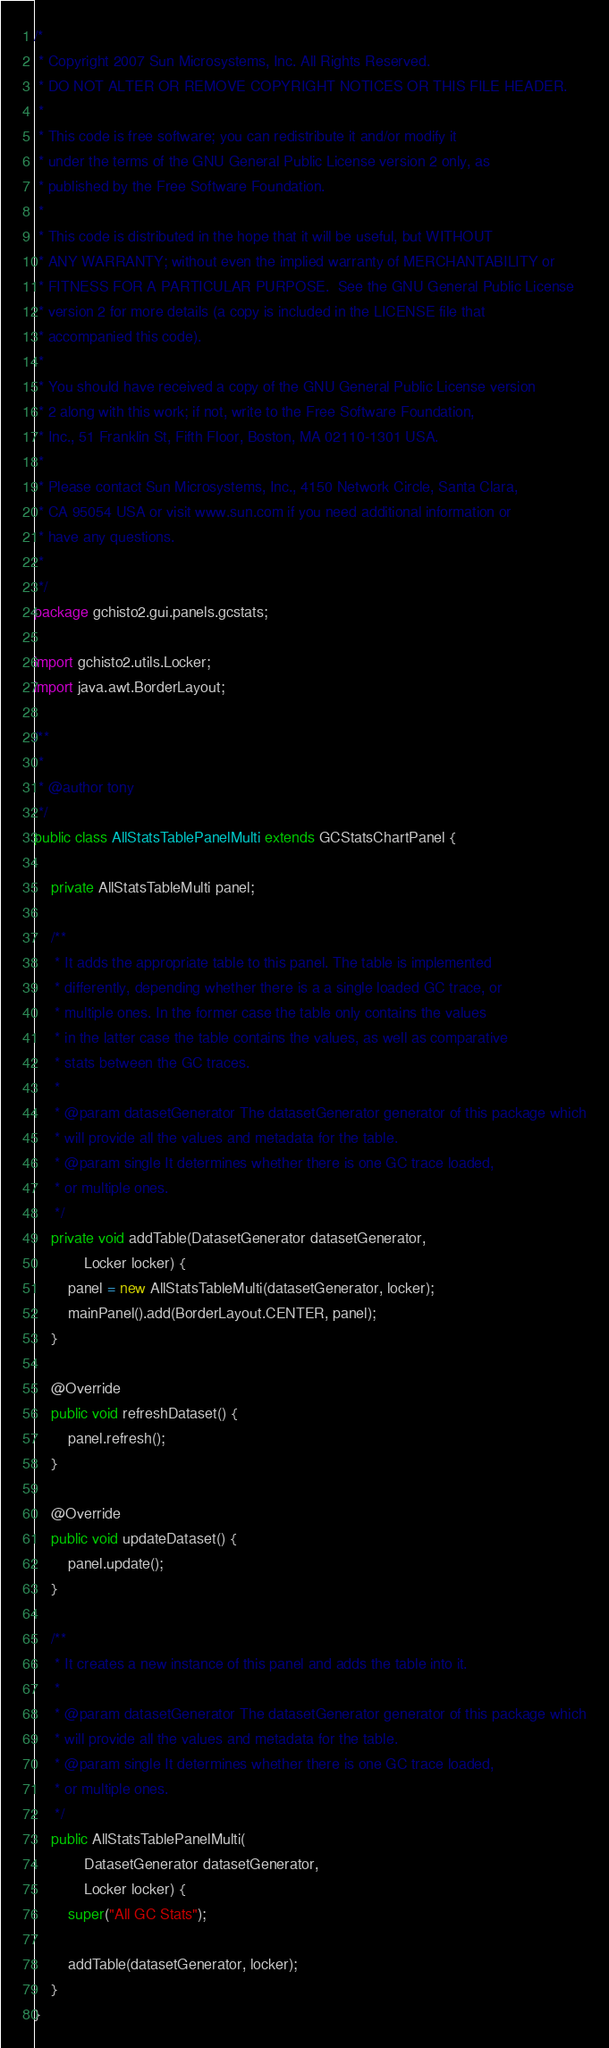Convert code to text. <code><loc_0><loc_0><loc_500><loc_500><_Java_>/*
 * Copyright 2007 Sun Microsystems, Inc. All Rights Reserved.
 * DO NOT ALTER OR REMOVE COPYRIGHT NOTICES OR THIS FILE HEADER.
 *
 * This code is free software; you can redistribute it and/or modify it
 * under the terms of the GNU General Public License version 2 only, as
 * published by the Free Software Foundation.
 *
 * This code is distributed in the hope that it will be useful, but WITHOUT
 * ANY WARRANTY; without even the implied warranty of MERCHANTABILITY or
 * FITNESS FOR A PARTICULAR PURPOSE.  See the GNU General Public License
 * version 2 for more details (a copy is included in the LICENSE file that
 * accompanied this code).
 *
 * You should have received a copy of the GNU General Public License version
 * 2 along with this work; if not, write to the Free Software Foundation,
 * Inc., 51 Franklin St, Fifth Floor, Boston, MA 02110-1301 USA.
 *
 * Please contact Sun Microsystems, Inc., 4150 Network Circle, Santa Clara,
 * CA 95054 USA or visit www.sun.com if you need additional information or
 * have any questions.
 *
 */
package gchisto2.gui.panels.gcstats;

import gchisto2.utils.Locker;
import java.awt.BorderLayout;

/**
 *
 * @author tony
 */
public class AllStatsTablePanelMulti extends GCStatsChartPanel {

    private AllStatsTableMulti panel;

    /**
     * It adds the appropriate table to this panel. The table is implemented
     * differently, depending whether there is a a single loaded GC trace, or
     * multiple ones. In the former case the table only contains the values
     * in the latter case the table contains the values, as well as comparative
     * stats between the GC traces.
     *
     * @param datasetGenerator The datasetGenerator generator of this package which
     * will provide all the values and metadata for the table.
     * @param single It determines whether there is one GC trace loaded,
     * or multiple ones.
     */
    private void addTable(DatasetGenerator datasetGenerator,
            Locker locker) {
        panel = new AllStatsTableMulti(datasetGenerator, locker);
        mainPanel().add(BorderLayout.CENTER, panel);
    }

    @Override
    public void refreshDataset() {
        panel.refresh();
    }

    @Override
    public void updateDataset() {
        panel.update();
    }

    /**
     * It creates a new instance of this panel and adds the table into it.
     *
     * @param datasetGenerator The datasetGenerator generator of this package which
     * will provide all the values and metadata for the table.
     * @param single It determines whether there is one GC trace loaded,
     * or multiple ones.
     */
    public AllStatsTablePanelMulti(
            DatasetGenerator datasetGenerator,
            Locker locker) {
        super("All GC Stats");

        addTable(datasetGenerator, locker);
    }
}
</code> 